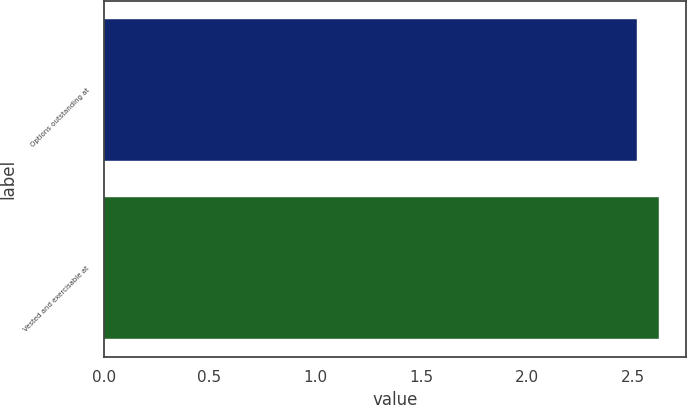Convert chart. <chart><loc_0><loc_0><loc_500><loc_500><bar_chart><fcel>Options outstanding at<fcel>Vested and exercisable at<nl><fcel>2.52<fcel>2.62<nl></chart> 